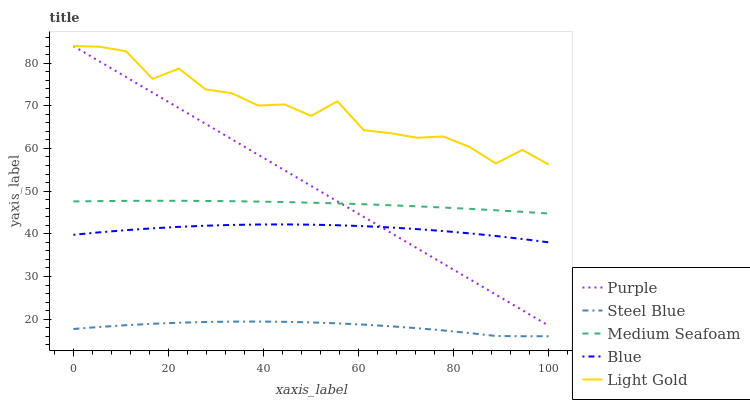Does Steel Blue have the minimum area under the curve?
Answer yes or no. Yes. Does Light Gold have the maximum area under the curve?
Answer yes or no. Yes. Does Blue have the minimum area under the curve?
Answer yes or no. No. Does Blue have the maximum area under the curve?
Answer yes or no. No. Is Purple the smoothest?
Answer yes or no. Yes. Is Light Gold the roughest?
Answer yes or no. Yes. Is Blue the smoothest?
Answer yes or no. No. Is Blue the roughest?
Answer yes or no. No. Does Steel Blue have the lowest value?
Answer yes or no. Yes. Does Blue have the lowest value?
Answer yes or no. No. Does Light Gold have the highest value?
Answer yes or no. Yes. Does Blue have the highest value?
Answer yes or no. No. Is Steel Blue less than Purple?
Answer yes or no. Yes. Is Medium Seafoam greater than Blue?
Answer yes or no. Yes. Does Medium Seafoam intersect Purple?
Answer yes or no. Yes. Is Medium Seafoam less than Purple?
Answer yes or no. No. Is Medium Seafoam greater than Purple?
Answer yes or no. No. Does Steel Blue intersect Purple?
Answer yes or no. No. 